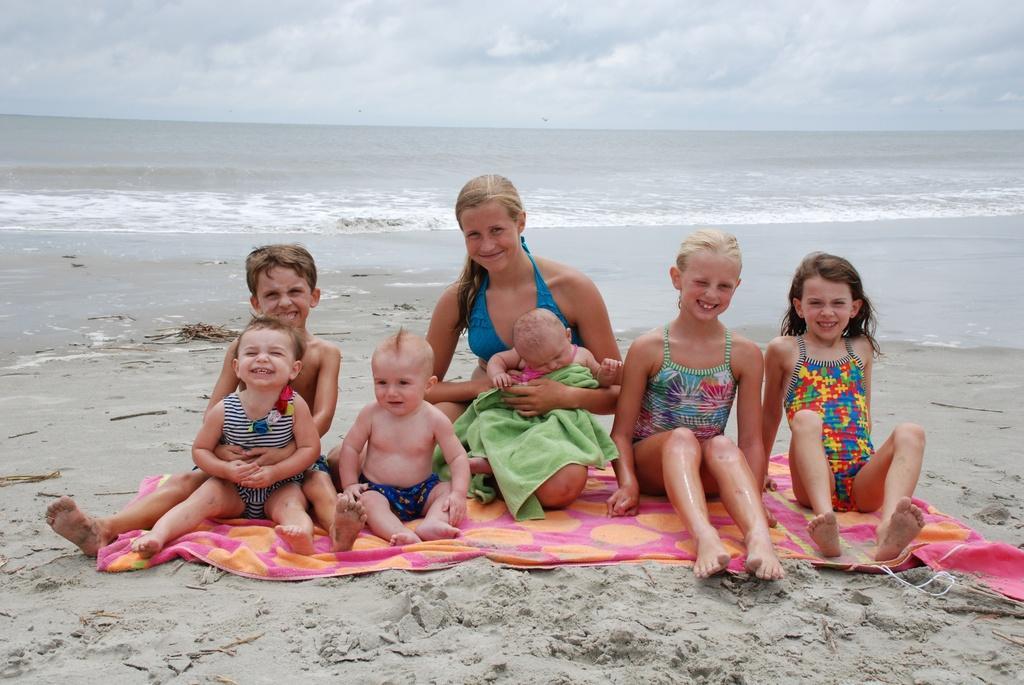How would you summarize this image in a sentence or two? In this image we can see a woman and a group of children sitting on a blanket which is on the seashore. In that we can see a woman holding a baby. On the backside we can see a large water body and the sky which looks cloudy. 